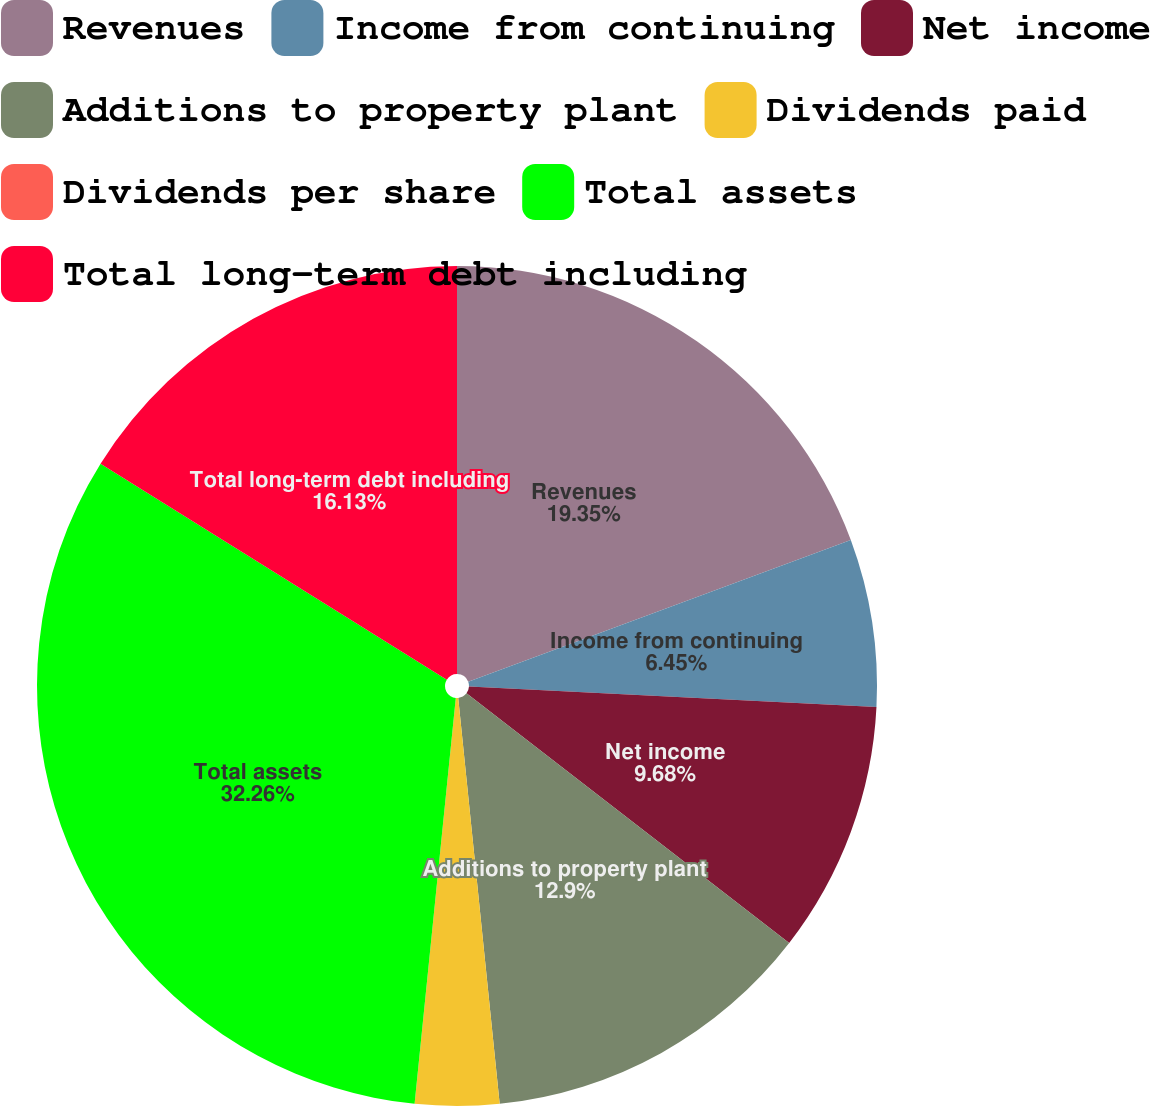Convert chart. <chart><loc_0><loc_0><loc_500><loc_500><pie_chart><fcel>Revenues<fcel>Income from continuing<fcel>Net income<fcel>Additions to property plant<fcel>Dividends paid<fcel>Dividends per share<fcel>Total assets<fcel>Total long-term debt including<nl><fcel>19.35%<fcel>6.45%<fcel>9.68%<fcel>12.9%<fcel>3.23%<fcel>0.0%<fcel>32.26%<fcel>16.13%<nl></chart> 